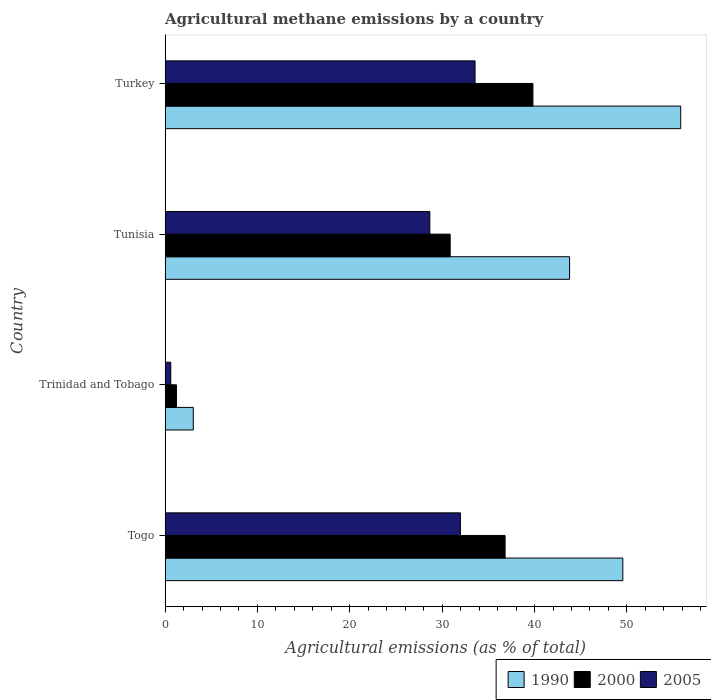How many different coloured bars are there?
Make the answer very short. 3. Are the number of bars on each tick of the Y-axis equal?
Provide a succinct answer. Yes. How many bars are there on the 2nd tick from the bottom?
Offer a very short reply. 3. What is the label of the 4th group of bars from the top?
Your answer should be very brief. Togo. In how many cases, is the number of bars for a given country not equal to the number of legend labels?
Ensure brevity in your answer.  0. What is the amount of agricultural methane emitted in 2005 in Tunisia?
Your response must be concise. 28.66. Across all countries, what is the maximum amount of agricultural methane emitted in 2000?
Offer a very short reply. 39.83. Across all countries, what is the minimum amount of agricultural methane emitted in 2005?
Provide a succinct answer. 0.62. In which country was the amount of agricultural methane emitted in 2005 maximum?
Ensure brevity in your answer.  Turkey. In which country was the amount of agricultural methane emitted in 1990 minimum?
Your answer should be very brief. Trinidad and Tobago. What is the total amount of agricultural methane emitted in 1990 in the graph?
Keep it short and to the point. 152.23. What is the difference between the amount of agricultural methane emitted in 2005 in Tunisia and that in Turkey?
Make the answer very short. -4.9. What is the difference between the amount of agricultural methane emitted in 1990 in Togo and the amount of agricultural methane emitted in 2000 in Turkey?
Make the answer very short. 9.73. What is the average amount of agricultural methane emitted in 2005 per country?
Offer a terse response. 23.7. What is the difference between the amount of agricultural methane emitted in 2005 and amount of agricultural methane emitted in 2000 in Togo?
Provide a succinct answer. -4.84. What is the ratio of the amount of agricultural methane emitted in 2005 in Tunisia to that in Turkey?
Offer a terse response. 0.85. What is the difference between the highest and the second highest amount of agricultural methane emitted in 2005?
Your answer should be compact. 1.58. What is the difference between the highest and the lowest amount of agricultural methane emitted in 2005?
Your response must be concise. 32.94. Is the sum of the amount of agricultural methane emitted in 1990 in Togo and Turkey greater than the maximum amount of agricultural methane emitted in 2005 across all countries?
Your answer should be compact. Yes. What does the 2nd bar from the bottom in Tunisia represents?
Provide a succinct answer. 2000. How many bars are there?
Provide a short and direct response. 12. What is the difference between two consecutive major ticks on the X-axis?
Your answer should be compact. 10. Are the values on the major ticks of X-axis written in scientific E-notation?
Ensure brevity in your answer.  No. Does the graph contain grids?
Provide a succinct answer. No. How are the legend labels stacked?
Give a very brief answer. Horizontal. What is the title of the graph?
Your response must be concise. Agricultural methane emissions by a country. What is the label or title of the X-axis?
Your answer should be compact. Agricultural emissions (as % of total). What is the Agricultural emissions (as % of total) of 1990 in Togo?
Make the answer very short. 49.56. What is the Agricultural emissions (as % of total) of 2000 in Togo?
Your response must be concise. 36.81. What is the Agricultural emissions (as % of total) of 2005 in Togo?
Provide a succinct answer. 31.98. What is the Agricultural emissions (as % of total) of 1990 in Trinidad and Tobago?
Make the answer very short. 3.05. What is the Agricultural emissions (as % of total) in 2000 in Trinidad and Tobago?
Offer a terse response. 1.23. What is the Agricultural emissions (as % of total) in 2005 in Trinidad and Tobago?
Your answer should be compact. 0.62. What is the Agricultural emissions (as % of total) of 1990 in Tunisia?
Ensure brevity in your answer.  43.79. What is the Agricultural emissions (as % of total) of 2000 in Tunisia?
Offer a very short reply. 30.87. What is the Agricultural emissions (as % of total) in 2005 in Tunisia?
Provide a succinct answer. 28.66. What is the Agricultural emissions (as % of total) of 1990 in Turkey?
Keep it short and to the point. 55.83. What is the Agricultural emissions (as % of total) in 2000 in Turkey?
Your answer should be very brief. 39.83. What is the Agricultural emissions (as % of total) in 2005 in Turkey?
Provide a short and direct response. 33.56. Across all countries, what is the maximum Agricultural emissions (as % of total) in 1990?
Your answer should be very brief. 55.83. Across all countries, what is the maximum Agricultural emissions (as % of total) of 2000?
Provide a short and direct response. 39.83. Across all countries, what is the maximum Agricultural emissions (as % of total) of 2005?
Provide a short and direct response. 33.56. Across all countries, what is the minimum Agricultural emissions (as % of total) in 1990?
Ensure brevity in your answer.  3.05. Across all countries, what is the minimum Agricultural emissions (as % of total) of 2000?
Provide a short and direct response. 1.23. Across all countries, what is the minimum Agricultural emissions (as % of total) in 2005?
Keep it short and to the point. 0.62. What is the total Agricultural emissions (as % of total) of 1990 in the graph?
Give a very brief answer. 152.23. What is the total Agricultural emissions (as % of total) in 2000 in the graph?
Offer a terse response. 108.74. What is the total Agricultural emissions (as % of total) in 2005 in the graph?
Offer a very short reply. 94.81. What is the difference between the Agricultural emissions (as % of total) in 1990 in Togo and that in Trinidad and Tobago?
Provide a short and direct response. 46.51. What is the difference between the Agricultural emissions (as % of total) in 2000 in Togo and that in Trinidad and Tobago?
Offer a very short reply. 35.58. What is the difference between the Agricultural emissions (as % of total) of 2005 in Togo and that in Trinidad and Tobago?
Your answer should be compact. 31.36. What is the difference between the Agricultural emissions (as % of total) in 1990 in Togo and that in Tunisia?
Keep it short and to the point. 5.77. What is the difference between the Agricultural emissions (as % of total) of 2000 in Togo and that in Tunisia?
Keep it short and to the point. 5.95. What is the difference between the Agricultural emissions (as % of total) of 2005 in Togo and that in Tunisia?
Offer a very short reply. 3.31. What is the difference between the Agricultural emissions (as % of total) of 1990 in Togo and that in Turkey?
Your response must be concise. -6.27. What is the difference between the Agricultural emissions (as % of total) of 2000 in Togo and that in Turkey?
Offer a very short reply. -3.01. What is the difference between the Agricultural emissions (as % of total) of 2005 in Togo and that in Turkey?
Offer a terse response. -1.58. What is the difference between the Agricultural emissions (as % of total) of 1990 in Trinidad and Tobago and that in Tunisia?
Ensure brevity in your answer.  -40.74. What is the difference between the Agricultural emissions (as % of total) in 2000 in Trinidad and Tobago and that in Tunisia?
Your response must be concise. -29.64. What is the difference between the Agricultural emissions (as % of total) of 2005 in Trinidad and Tobago and that in Tunisia?
Your answer should be compact. -28.05. What is the difference between the Agricultural emissions (as % of total) in 1990 in Trinidad and Tobago and that in Turkey?
Give a very brief answer. -52.78. What is the difference between the Agricultural emissions (as % of total) of 2000 in Trinidad and Tobago and that in Turkey?
Give a very brief answer. -38.6. What is the difference between the Agricultural emissions (as % of total) in 2005 in Trinidad and Tobago and that in Turkey?
Provide a succinct answer. -32.94. What is the difference between the Agricultural emissions (as % of total) in 1990 in Tunisia and that in Turkey?
Your answer should be compact. -12.03. What is the difference between the Agricultural emissions (as % of total) of 2000 in Tunisia and that in Turkey?
Offer a very short reply. -8.96. What is the difference between the Agricultural emissions (as % of total) in 2005 in Tunisia and that in Turkey?
Your answer should be compact. -4.9. What is the difference between the Agricultural emissions (as % of total) in 1990 in Togo and the Agricultural emissions (as % of total) in 2000 in Trinidad and Tobago?
Provide a succinct answer. 48.33. What is the difference between the Agricultural emissions (as % of total) in 1990 in Togo and the Agricultural emissions (as % of total) in 2005 in Trinidad and Tobago?
Offer a terse response. 48.94. What is the difference between the Agricultural emissions (as % of total) of 2000 in Togo and the Agricultural emissions (as % of total) of 2005 in Trinidad and Tobago?
Offer a terse response. 36.2. What is the difference between the Agricultural emissions (as % of total) of 1990 in Togo and the Agricultural emissions (as % of total) of 2000 in Tunisia?
Keep it short and to the point. 18.69. What is the difference between the Agricultural emissions (as % of total) of 1990 in Togo and the Agricultural emissions (as % of total) of 2005 in Tunisia?
Make the answer very short. 20.9. What is the difference between the Agricultural emissions (as % of total) of 2000 in Togo and the Agricultural emissions (as % of total) of 2005 in Tunisia?
Your answer should be very brief. 8.15. What is the difference between the Agricultural emissions (as % of total) in 1990 in Togo and the Agricultural emissions (as % of total) in 2000 in Turkey?
Provide a short and direct response. 9.73. What is the difference between the Agricultural emissions (as % of total) of 1990 in Togo and the Agricultural emissions (as % of total) of 2005 in Turkey?
Offer a very short reply. 16. What is the difference between the Agricultural emissions (as % of total) of 2000 in Togo and the Agricultural emissions (as % of total) of 2005 in Turkey?
Keep it short and to the point. 3.25. What is the difference between the Agricultural emissions (as % of total) of 1990 in Trinidad and Tobago and the Agricultural emissions (as % of total) of 2000 in Tunisia?
Your response must be concise. -27.81. What is the difference between the Agricultural emissions (as % of total) in 1990 in Trinidad and Tobago and the Agricultural emissions (as % of total) in 2005 in Tunisia?
Keep it short and to the point. -25.61. What is the difference between the Agricultural emissions (as % of total) of 2000 in Trinidad and Tobago and the Agricultural emissions (as % of total) of 2005 in Tunisia?
Keep it short and to the point. -27.43. What is the difference between the Agricultural emissions (as % of total) of 1990 in Trinidad and Tobago and the Agricultural emissions (as % of total) of 2000 in Turkey?
Provide a succinct answer. -36.78. What is the difference between the Agricultural emissions (as % of total) of 1990 in Trinidad and Tobago and the Agricultural emissions (as % of total) of 2005 in Turkey?
Your response must be concise. -30.51. What is the difference between the Agricultural emissions (as % of total) in 2000 in Trinidad and Tobago and the Agricultural emissions (as % of total) in 2005 in Turkey?
Offer a terse response. -32.33. What is the difference between the Agricultural emissions (as % of total) in 1990 in Tunisia and the Agricultural emissions (as % of total) in 2000 in Turkey?
Your answer should be very brief. 3.97. What is the difference between the Agricultural emissions (as % of total) in 1990 in Tunisia and the Agricultural emissions (as % of total) in 2005 in Turkey?
Keep it short and to the point. 10.23. What is the difference between the Agricultural emissions (as % of total) of 2000 in Tunisia and the Agricultural emissions (as % of total) of 2005 in Turkey?
Provide a short and direct response. -2.69. What is the average Agricultural emissions (as % of total) in 1990 per country?
Offer a terse response. 38.06. What is the average Agricultural emissions (as % of total) of 2000 per country?
Your response must be concise. 27.18. What is the average Agricultural emissions (as % of total) in 2005 per country?
Offer a terse response. 23.7. What is the difference between the Agricultural emissions (as % of total) in 1990 and Agricultural emissions (as % of total) in 2000 in Togo?
Your answer should be compact. 12.75. What is the difference between the Agricultural emissions (as % of total) in 1990 and Agricultural emissions (as % of total) in 2005 in Togo?
Ensure brevity in your answer.  17.58. What is the difference between the Agricultural emissions (as % of total) of 2000 and Agricultural emissions (as % of total) of 2005 in Togo?
Keep it short and to the point. 4.84. What is the difference between the Agricultural emissions (as % of total) in 1990 and Agricultural emissions (as % of total) in 2000 in Trinidad and Tobago?
Your answer should be compact. 1.82. What is the difference between the Agricultural emissions (as % of total) in 1990 and Agricultural emissions (as % of total) in 2005 in Trinidad and Tobago?
Offer a terse response. 2.44. What is the difference between the Agricultural emissions (as % of total) of 2000 and Agricultural emissions (as % of total) of 2005 in Trinidad and Tobago?
Provide a short and direct response. 0.61. What is the difference between the Agricultural emissions (as % of total) in 1990 and Agricultural emissions (as % of total) in 2000 in Tunisia?
Ensure brevity in your answer.  12.93. What is the difference between the Agricultural emissions (as % of total) of 1990 and Agricultural emissions (as % of total) of 2005 in Tunisia?
Offer a terse response. 15.13. What is the difference between the Agricultural emissions (as % of total) of 2000 and Agricultural emissions (as % of total) of 2005 in Tunisia?
Keep it short and to the point. 2.2. What is the difference between the Agricultural emissions (as % of total) of 1990 and Agricultural emissions (as % of total) of 2000 in Turkey?
Offer a very short reply. 16. What is the difference between the Agricultural emissions (as % of total) of 1990 and Agricultural emissions (as % of total) of 2005 in Turkey?
Provide a short and direct response. 22.27. What is the difference between the Agricultural emissions (as % of total) in 2000 and Agricultural emissions (as % of total) in 2005 in Turkey?
Your answer should be very brief. 6.27. What is the ratio of the Agricultural emissions (as % of total) in 1990 in Togo to that in Trinidad and Tobago?
Provide a succinct answer. 16.24. What is the ratio of the Agricultural emissions (as % of total) of 2000 in Togo to that in Trinidad and Tobago?
Offer a terse response. 29.92. What is the ratio of the Agricultural emissions (as % of total) of 2005 in Togo to that in Trinidad and Tobago?
Offer a terse response. 51.91. What is the ratio of the Agricultural emissions (as % of total) of 1990 in Togo to that in Tunisia?
Give a very brief answer. 1.13. What is the ratio of the Agricultural emissions (as % of total) of 2000 in Togo to that in Tunisia?
Your answer should be very brief. 1.19. What is the ratio of the Agricultural emissions (as % of total) of 2005 in Togo to that in Tunisia?
Your answer should be very brief. 1.12. What is the ratio of the Agricultural emissions (as % of total) in 1990 in Togo to that in Turkey?
Provide a succinct answer. 0.89. What is the ratio of the Agricultural emissions (as % of total) of 2000 in Togo to that in Turkey?
Provide a short and direct response. 0.92. What is the ratio of the Agricultural emissions (as % of total) in 2005 in Togo to that in Turkey?
Keep it short and to the point. 0.95. What is the ratio of the Agricultural emissions (as % of total) of 1990 in Trinidad and Tobago to that in Tunisia?
Provide a succinct answer. 0.07. What is the ratio of the Agricultural emissions (as % of total) of 2000 in Trinidad and Tobago to that in Tunisia?
Your answer should be very brief. 0.04. What is the ratio of the Agricultural emissions (as % of total) of 2005 in Trinidad and Tobago to that in Tunisia?
Ensure brevity in your answer.  0.02. What is the ratio of the Agricultural emissions (as % of total) in 1990 in Trinidad and Tobago to that in Turkey?
Provide a short and direct response. 0.05. What is the ratio of the Agricultural emissions (as % of total) of 2000 in Trinidad and Tobago to that in Turkey?
Make the answer very short. 0.03. What is the ratio of the Agricultural emissions (as % of total) in 2005 in Trinidad and Tobago to that in Turkey?
Your answer should be compact. 0.02. What is the ratio of the Agricultural emissions (as % of total) of 1990 in Tunisia to that in Turkey?
Offer a terse response. 0.78. What is the ratio of the Agricultural emissions (as % of total) in 2000 in Tunisia to that in Turkey?
Your response must be concise. 0.78. What is the ratio of the Agricultural emissions (as % of total) in 2005 in Tunisia to that in Turkey?
Offer a terse response. 0.85. What is the difference between the highest and the second highest Agricultural emissions (as % of total) of 1990?
Give a very brief answer. 6.27. What is the difference between the highest and the second highest Agricultural emissions (as % of total) in 2000?
Offer a very short reply. 3.01. What is the difference between the highest and the second highest Agricultural emissions (as % of total) in 2005?
Your answer should be very brief. 1.58. What is the difference between the highest and the lowest Agricultural emissions (as % of total) of 1990?
Make the answer very short. 52.78. What is the difference between the highest and the lowest Agricultural emissions (as % of total) of 2000?
Offer a terse response. 38.6. What is the difference between the highest and the lowest Agricultural emissions (as % of total) of 2005?
Your response must be concise. 32.94. 